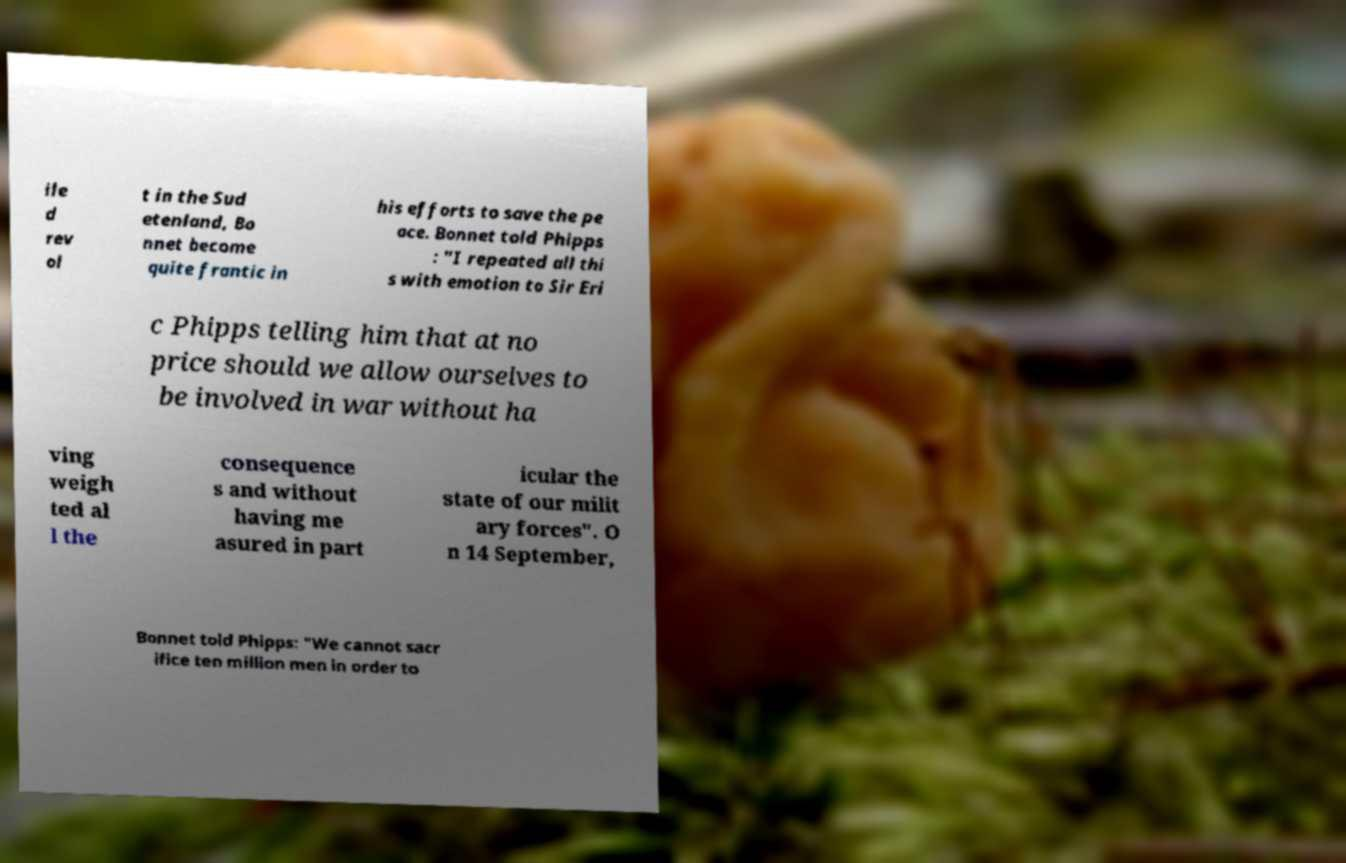Can you read and provide the text displayed in the image?This photo seems to have some interesting text. Can you extract and type it out for me? ile d rev ol t in the Sud etenland, Bo nnet become quite frantic in his efforts to save the pe ace. Bonnet told Phipps : "I repeated all thi s with emotion to Sir Eri c Phipps telling him that at no price should we allow ourselves to be involved in war without ha ving weigh ted al l the consequence s and without having me asured in part icular the state of our milit ary forces". O n 14 September, Bonnet told Phipps: "We cannot sacr ifice ten million men in order to 